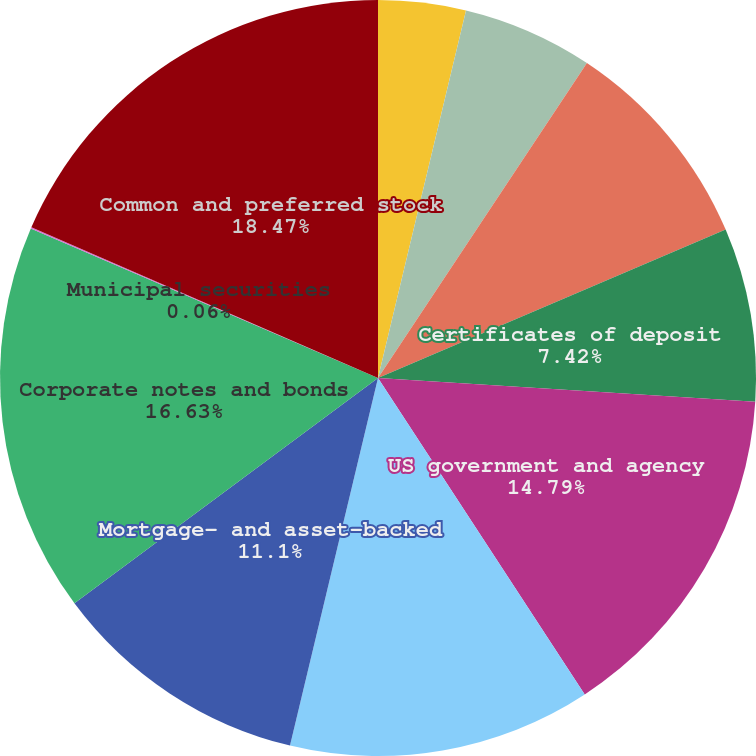Convert chart to OTSL. <chart><loc_0><loc_0><loc_500><loc_500><pie_chart><fcel>Cash<fcel>Mutual funds<fcel>Commercial paper<fcel>Certificates of deposit<fcel>US government and agency<fcel>Foreign government bonds<fcel>Mortgage- and asset-backed<fcel>Corporate notes and bonds<fcel>Municipal securities<fcel>Common and preferred stock<nl><fcel>3.74%<fcel>5.58%<fcel>9.26%<fcel>7.42%<fcel>14.79%<fcel>12.95%<fcel>11.1%<fcel>16.63%<fcel>0.06%<fcel>18.47%<nl></chart> 